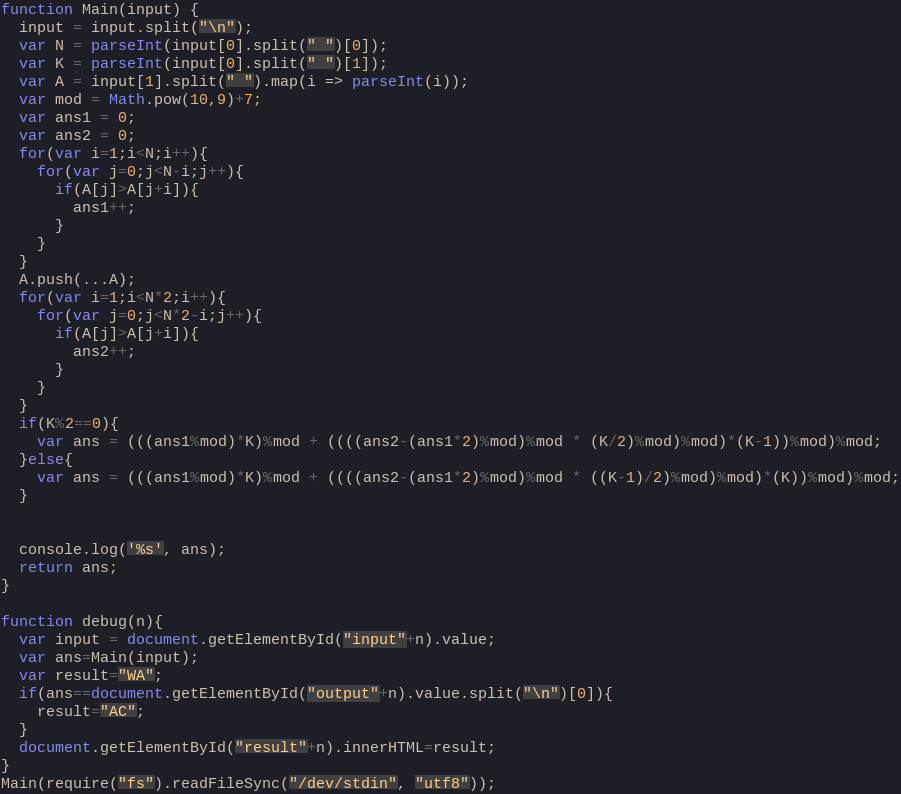<code> <loc_0><loc_0><loc_500><loc_500><_JavaScript_>function Main(input) {
  input = input.split("\n");
  var N = parseInt(input[0].split(" ")[0]);
  var K = parseInt(input[0].split(" ")[1]);
  var A = input[1].split(" ").map(i => parseInt(i));
  var mod = Math.pow(10,9)+7;
  var ans1 = 0;
  var ans2 = 0;
  for(var i=1;i<N;i++){
    for(var j=0;j<N-i;j++){
      if(A[j]>A[j+i]){
        ans1++;
      }
    }
  }
  A.push(...A);
  for(var i=1;i<N*2;i++){
    for(var j=0;j<N*2-i;j++){
      if(A[j]>A[j+i]){
        ans2++;
      }
    }
  }
  if(K%2==0){
    var ans = (((ans1%mod)*K)%mod + ((((ans2-(ans1*2)%mod)%mod * (K/2)%mod)%mod)*(K-1))%mod)%mod;
  }else{
    var ans = (((ans1%mod)*K)%mod + ((((ans2-(ans1*2)%mod)%mod * ((K-1)/2)%mod)%mod)*(K))%mod)%mod;
  }


  console.log('%s', ans);
  return ans;
}

function debug(n){
  var input = document.getElementById("input"+n).value;
  var ans=Main(input);
  var result="WA";
  if(ans==document.getElementById("output"+n).value.split("\n")[0]){
    result="AC";
  }
  document.getElementById("result"+n).innerHTML=result;
}
Main(require("fs").readFileSync("/dev/stdin", "utf8"));</code> 